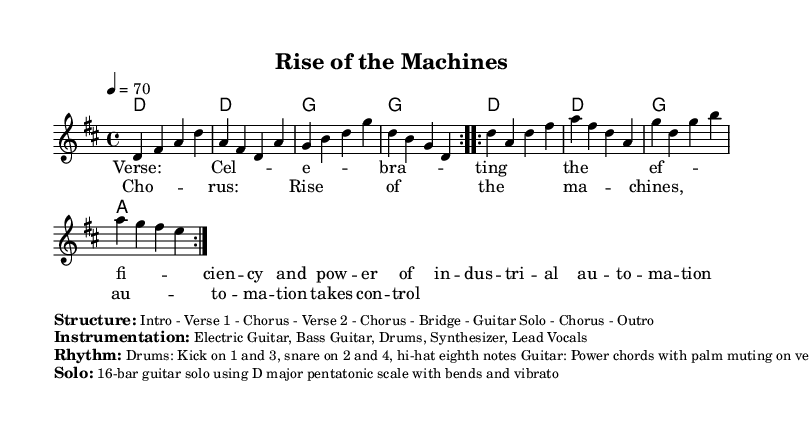What is the key signature of this music? The key signature is D major, indicated by the presence of two sharps (F# and C#) in the key.
Answer: D major What is the time signature of this piece? The time signature is 4/4, which appears at the beginning of the score and signifies four beats in a measure.
Answer: 4/4 What is the tempo marking for this piece? The tempo marking is 4 = 70, meaning there are 70 quarter-note beats per minute, establishing the speed of the music.
Answer: 70 How many verses are in the structure of the music? The structure indicates two verses with the repeated lyrical sections labeled "Verse 1" and "Verse 2," confirming their presence in the format.
Answer: 2 What instruments are included in the instrumentation? The listed instruments are Electric Guitar, Bass Guitar, Drums, Synthesizer, and Lead Vocals, which together create a full rock sound typical of the genre.
Answer: Electric Guitar, Bass Guitar, Drums, Synthesizer, Lead Vocals What technique is used for the guitar during the verses? The technique described is palm muting, which alters the tone, making it more percussive during the verses, contrasting with the open chords of the chorus.
Answer: Palm muting 